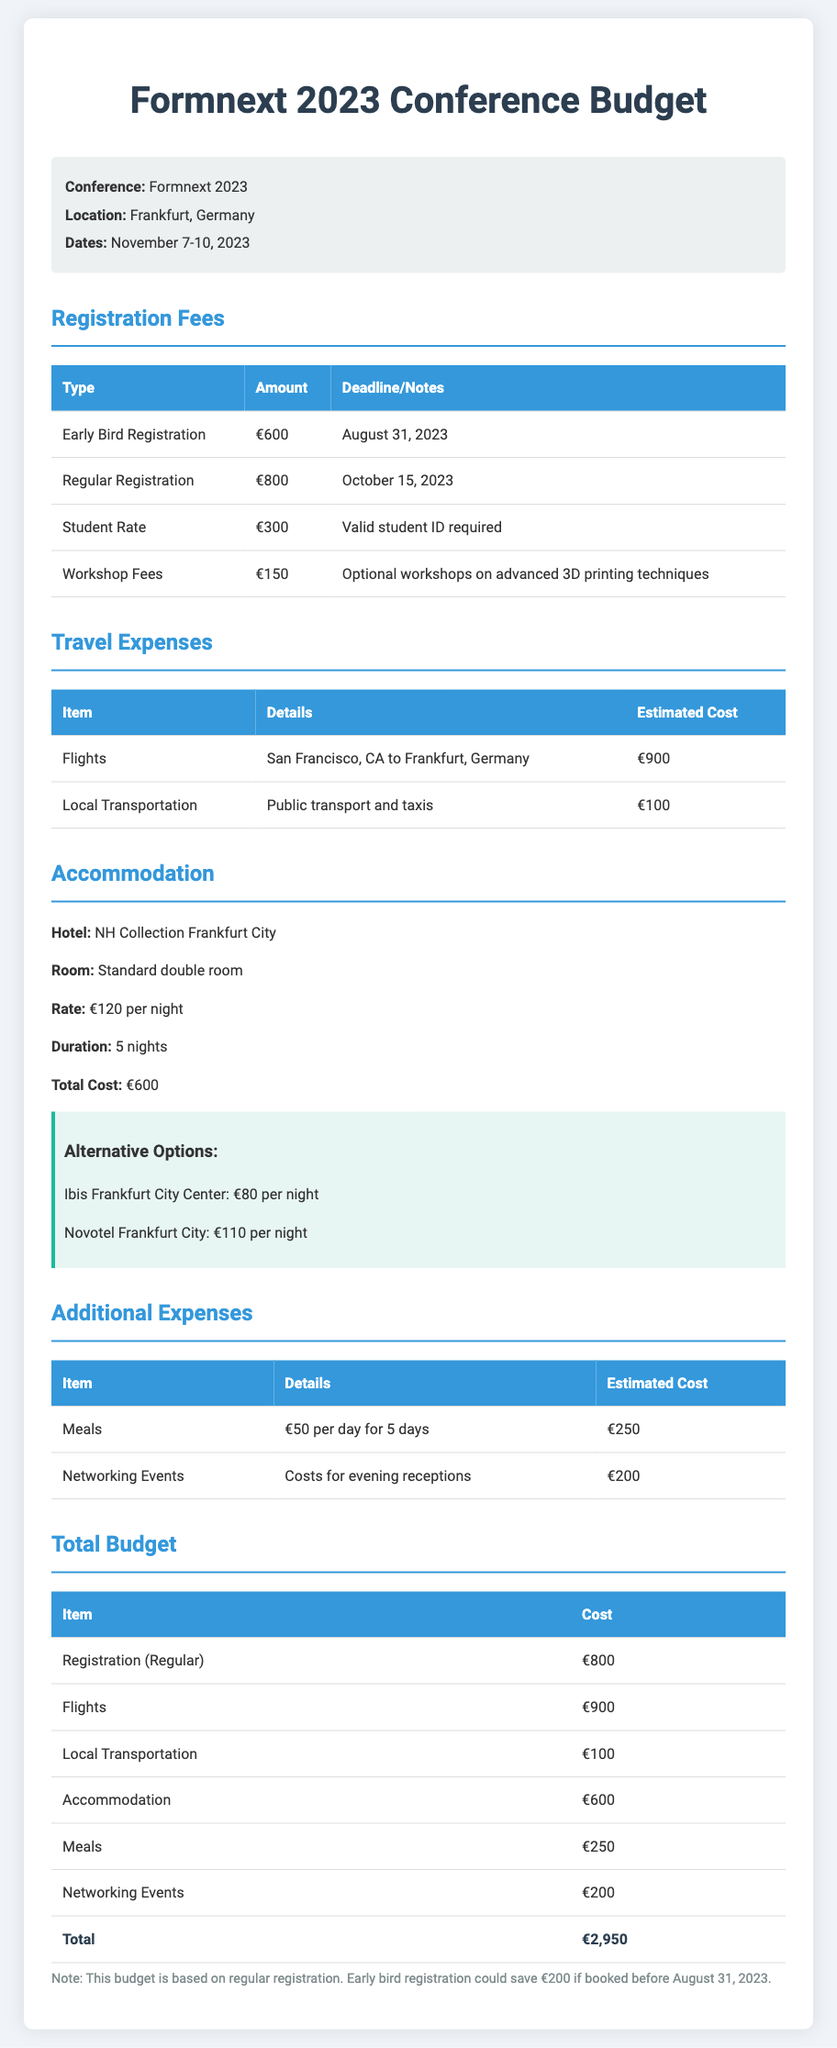what is the total estimated cost for the conference? The total estimated cost is obtained from the section summarizing all expenses, which is €2,950.
Answer: €2,950 what is the early bird registration fee? The early bird registration fee is listed in the registration section of the document, which is €600.
Answer: €600 how many nights will the accommodation last? The duration of the accommodation is specified, which is 5 nights.
Answer: 5 nights what is the cost of local transportation? The estimated cost for local transportation is provided in the travel expenses section, which is €100.
Answer: €100 what is the total accommodation cost? The total accommodation cost is derived from the hotel rate and duration, equaling €600.
Answer: €600 how much can be saved with early bird registration? The note mentions a saving of €200 if the early bird registration is booked before the deadline.
Answer: €200 what is the registration deadline for regular registration? The registration deadline for regular registration is clearly stated in the document, which is October 15, 2023.
Answer: October 15, 2023 which hotel is listed for accommodation? The hotel specified in the accommodation section is NH Collection Frankfurt City.
Answer: NH Collection Frankfurt City what is the cost of meals for 5 days? The total cost for meals can be found in the additional expenses table, which is €250.
Answer: €250 